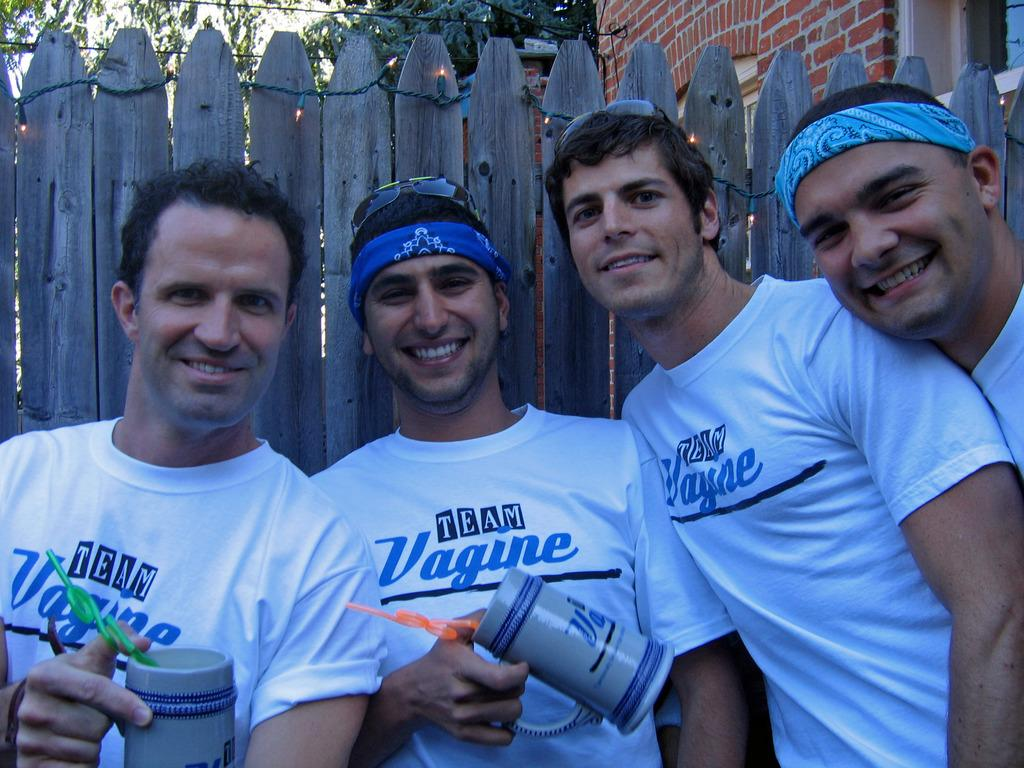Provide a one-sentence caption for the provided image. A group of men posing next to a fence all wearing a t-shirt with the logo TEAM Vagine on them. 